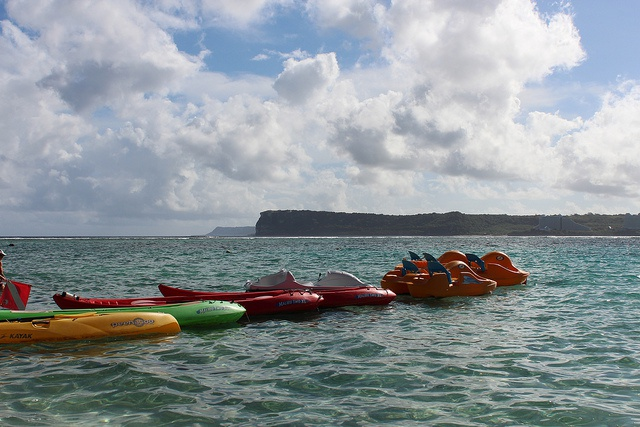Describe the objects in this image and their specific colors. I can see boat in gray, maroon, black, and olive tones, boat in gray, black, darkgreen, green, and teal tones, boat in gray, black, maroon, and darkgray tones, boat in gray, black, maroon, and brown tones, and boat in gray, black, maroon, navy, and brown tones in this image. 